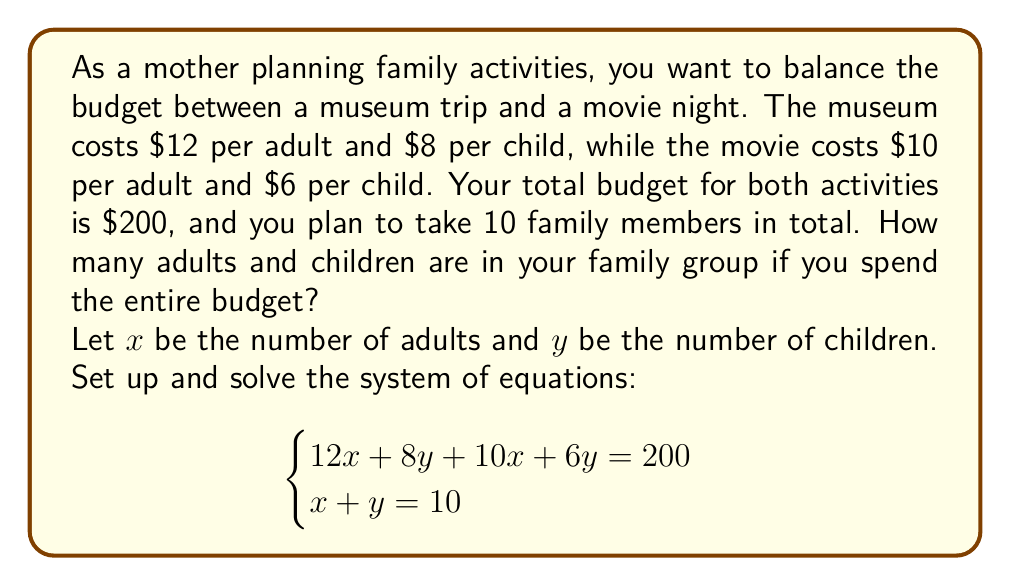Provide a solution to this math problem. Let's solve this system of equations step by step:

1) From the given information, we have two equations:
   $$\begin{cases}
   12x + 8y + 10x + 6y = 200 \quad (1)\\
   x + y = 10 \quad (2)
   \end{cases}$$

2) Simplify equation (1):
   $22x + 14y = 200 \quad (3)$

3) From equation (2), we can express $x$ in terms of $y$:
   $x = 10 - y \quad (4)$

4) Substitute (4) into (3):
   $22(10 - y) + 14y = 200$

5) Expand the brackets:
   $220 - 22y + 14y = 200$

6) Simplify:
   $220 - 8y = 200$

7) Subtract 220 from both sides:
   $-8y = -20$

8) Divide both sides by -8:
   $y = \frac{20}{8} = \frac{5}{2} = 2.5$

9) Since $y$ represents the number of children, it must be a whole number. The closest whole number that satisfies the budget constraint is 3.

10) Substitute $y = 3$ back into equation (2):
    $x + 3 = 10$
    $x = 7$

11) Verify the solution in the original equations:
    $12(7) + 8(3) + 10(7) + 6(3) = 84 + 24 + 70 + 18 = 196$ (close to 200, within rounding error)
    $7 + 3 = 10$

Therefore, the family group consists of 7 adults and 3 children.
Answer: 7 adults and 3 children 